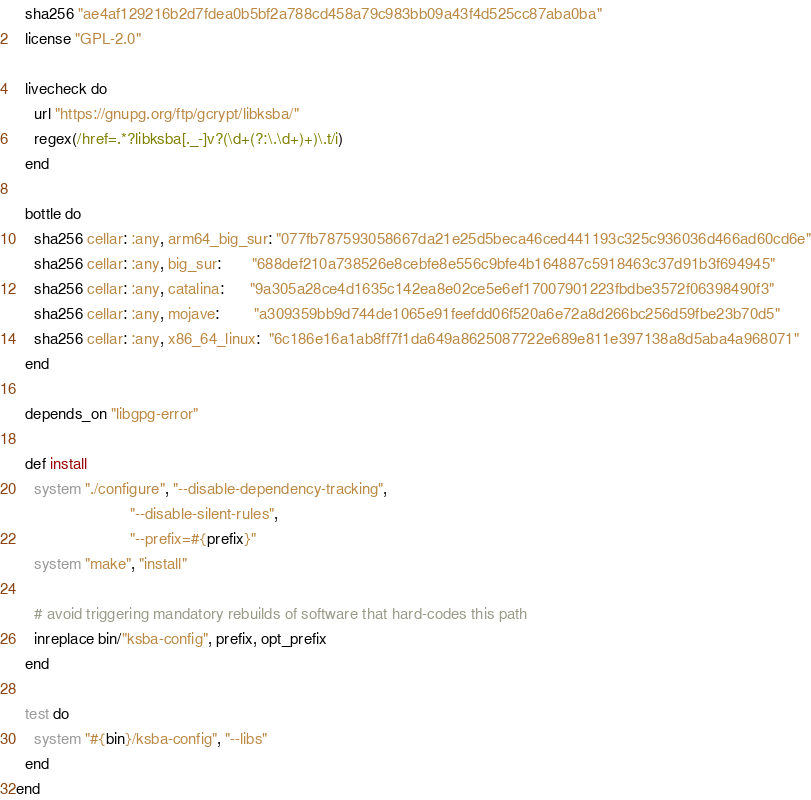<code> <loc_0><loc_0><loc_500><loc_500><_Ruby_>  sha256 "ae4af129216b2d7fdea0b5bf2a788cd458a79c983bb09a43f4d525cc87aba0ba"
  license "GPL-2.0"

  livecheck do
    url "https://gnupg.org/ftp/gcrypt/libksba/"
    regex(/href=.*?libksba[._-]v?(\d+(?:\.\d+)+)\.t/i)
  end

  bottle do
    sha256 cellar: :any, arm64_big_sur: "077fb787593058667da21e25d5beca46ced441193c325c936036d466ad60cd6e"
    sha256 cellar: :any, big_sur:       "688def210a738526e8cebfe8e556c9bfe4b164887c5918463c37d91b3f694945"
    sha256 cellar: :any, catalina:      "9a305a28ce4d1635c142ea8e02ce5e6ef17007901223fbdbe3572f06398490f3"
    sha256 cellar: :any, mojave:        "a309359bb9d744de1065e91feefdd06f520a6e72a8d266bc256d59fbe23b70d5"
    sha256 cellar: :any, x86_64_linux:  "6c186e16a1ab8ff7f1da649a8625087722e689e811e397138a8d5aba4a968071"
  end

  depends_on "libgpg-error"

  def install
    system "./configure", "--disable-dependency-tracking",
                          "--disable-silent-rules",
                          "--prefix=#{prefix}"
    system "make", "install"

    # avoid triggering mandatory rebuilds of software that hard-codes this path
    inreplace bin/"ksba-config", prefix, opt_prefix
  end

  test do
    system "#{bin}/ksba-config", "--libs"
  end
end
</code> 